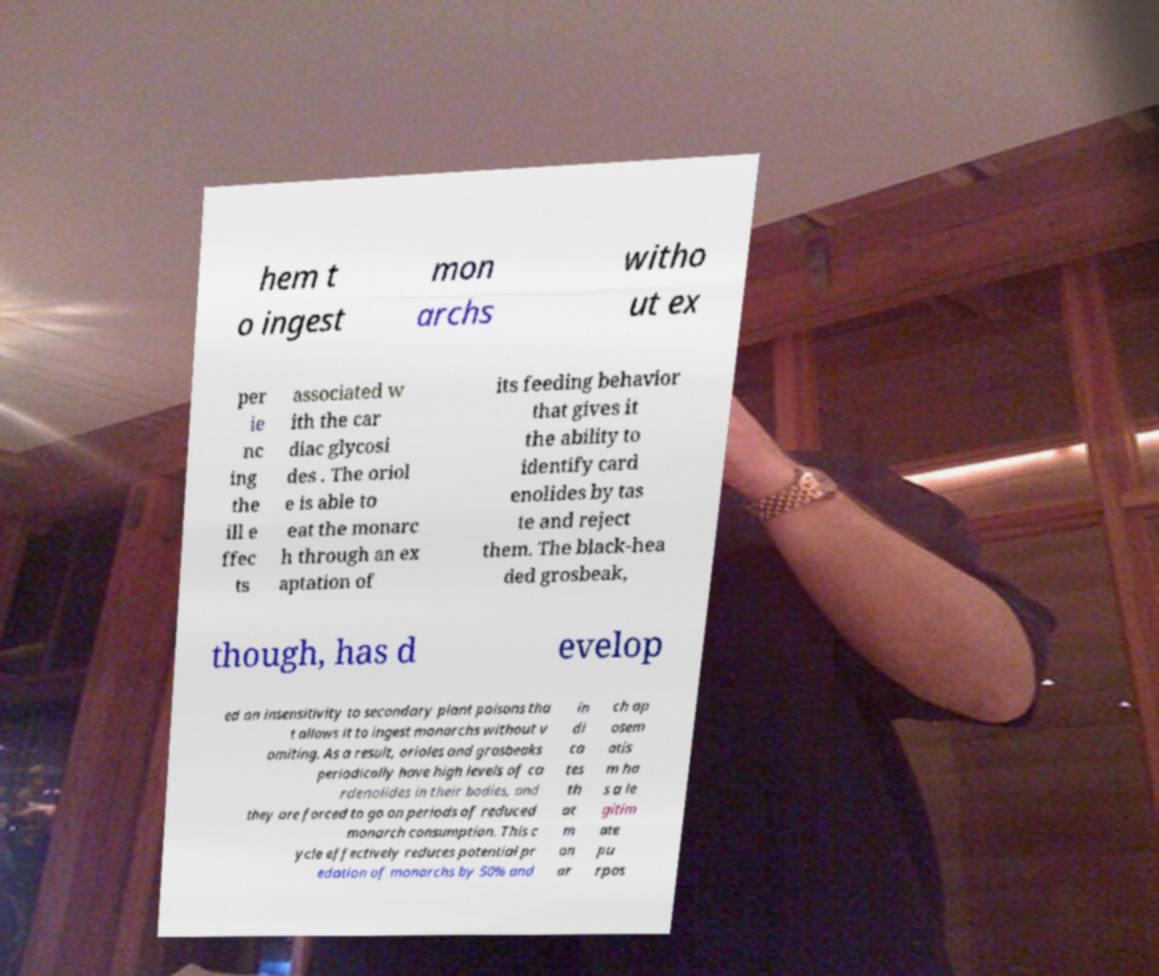Could you extract and type out the text from this image? hem t o ingest mon archs witho ut ex per ie nc ing the ill e ffec ts associated w ith the car diac glycosi des . The oriol e is able to eat the monarc h through an ex aptation of its feeding behavior that gives it the ability to identify card enolides by tas te and reject them. The black-hea ded grosbeak, though, has d evelop ed an insensitivity to secondary plant poisons tha t allows it to ingest monarchs without v omiting. As a result, orioles and grosbeaks periodically have high levels of ca rdenolides in their bodies, and they are forced to go on periods of reduced monarch consumption. This c ycle effectively reduces potential pr edation of monarchs by 50% and in di ca tes th at m on ar ch ap osem atis m ha s a le gitim ate pu rpos 